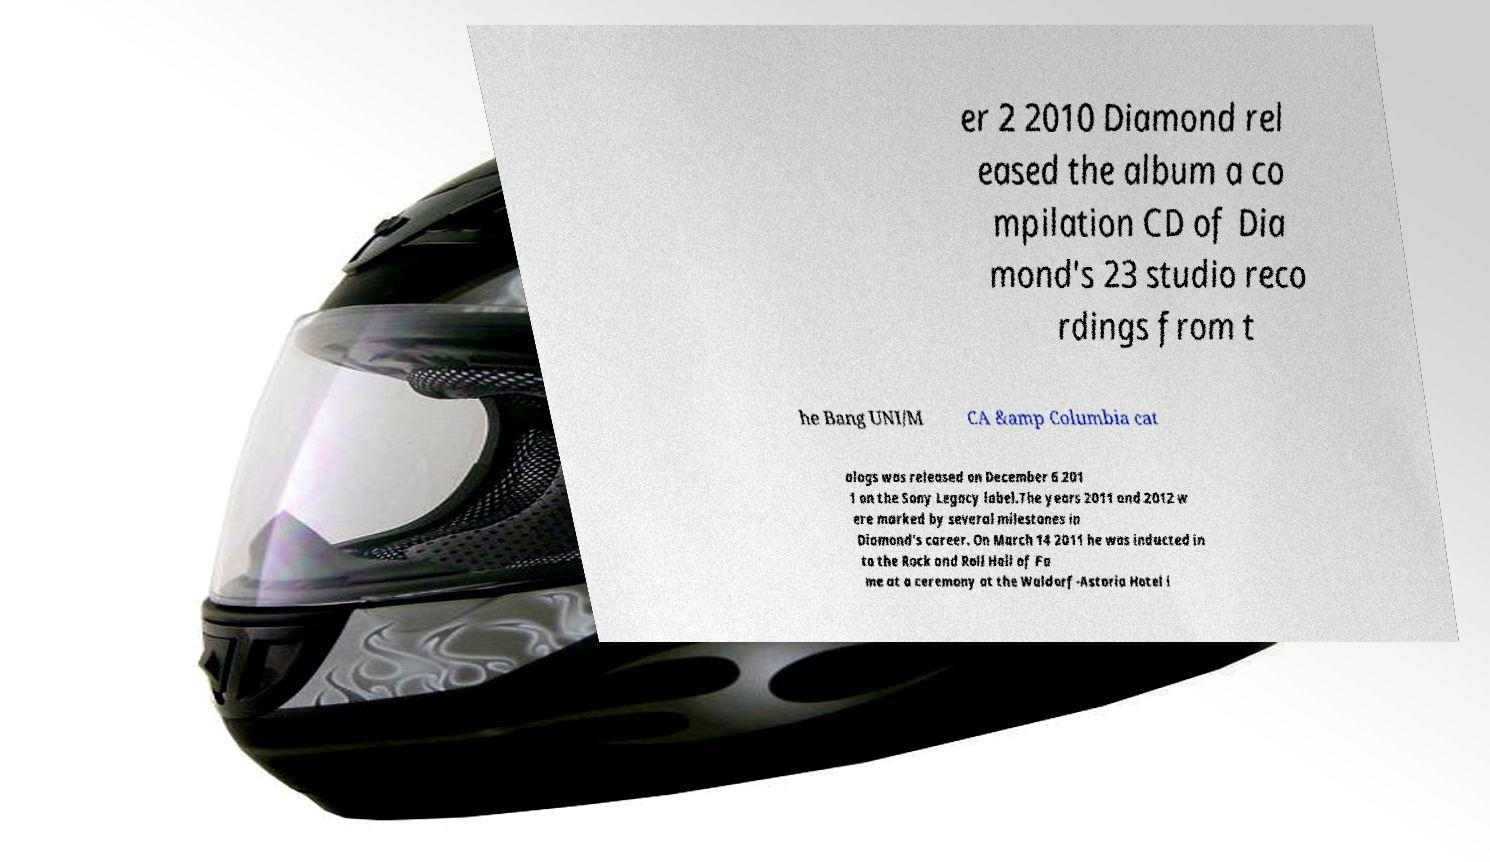Could you extract and type out the text from this image? er 2 2010 Diamond rel eased the album a co mpilation CD of Dia mond's 23 studio reco rdings from t he Bang UNI/M CA &amp Columbia cat alogs was released on December 6 201 1 on the Sony Legacy label.The years 2011 and 2012 w ere marked by several milestones in Diamond's career. On March 14 2011 he was inducted in to the Rock and Roll Hall of Fa me at a ceremony at the Waldorf-Astoria Hotel i 